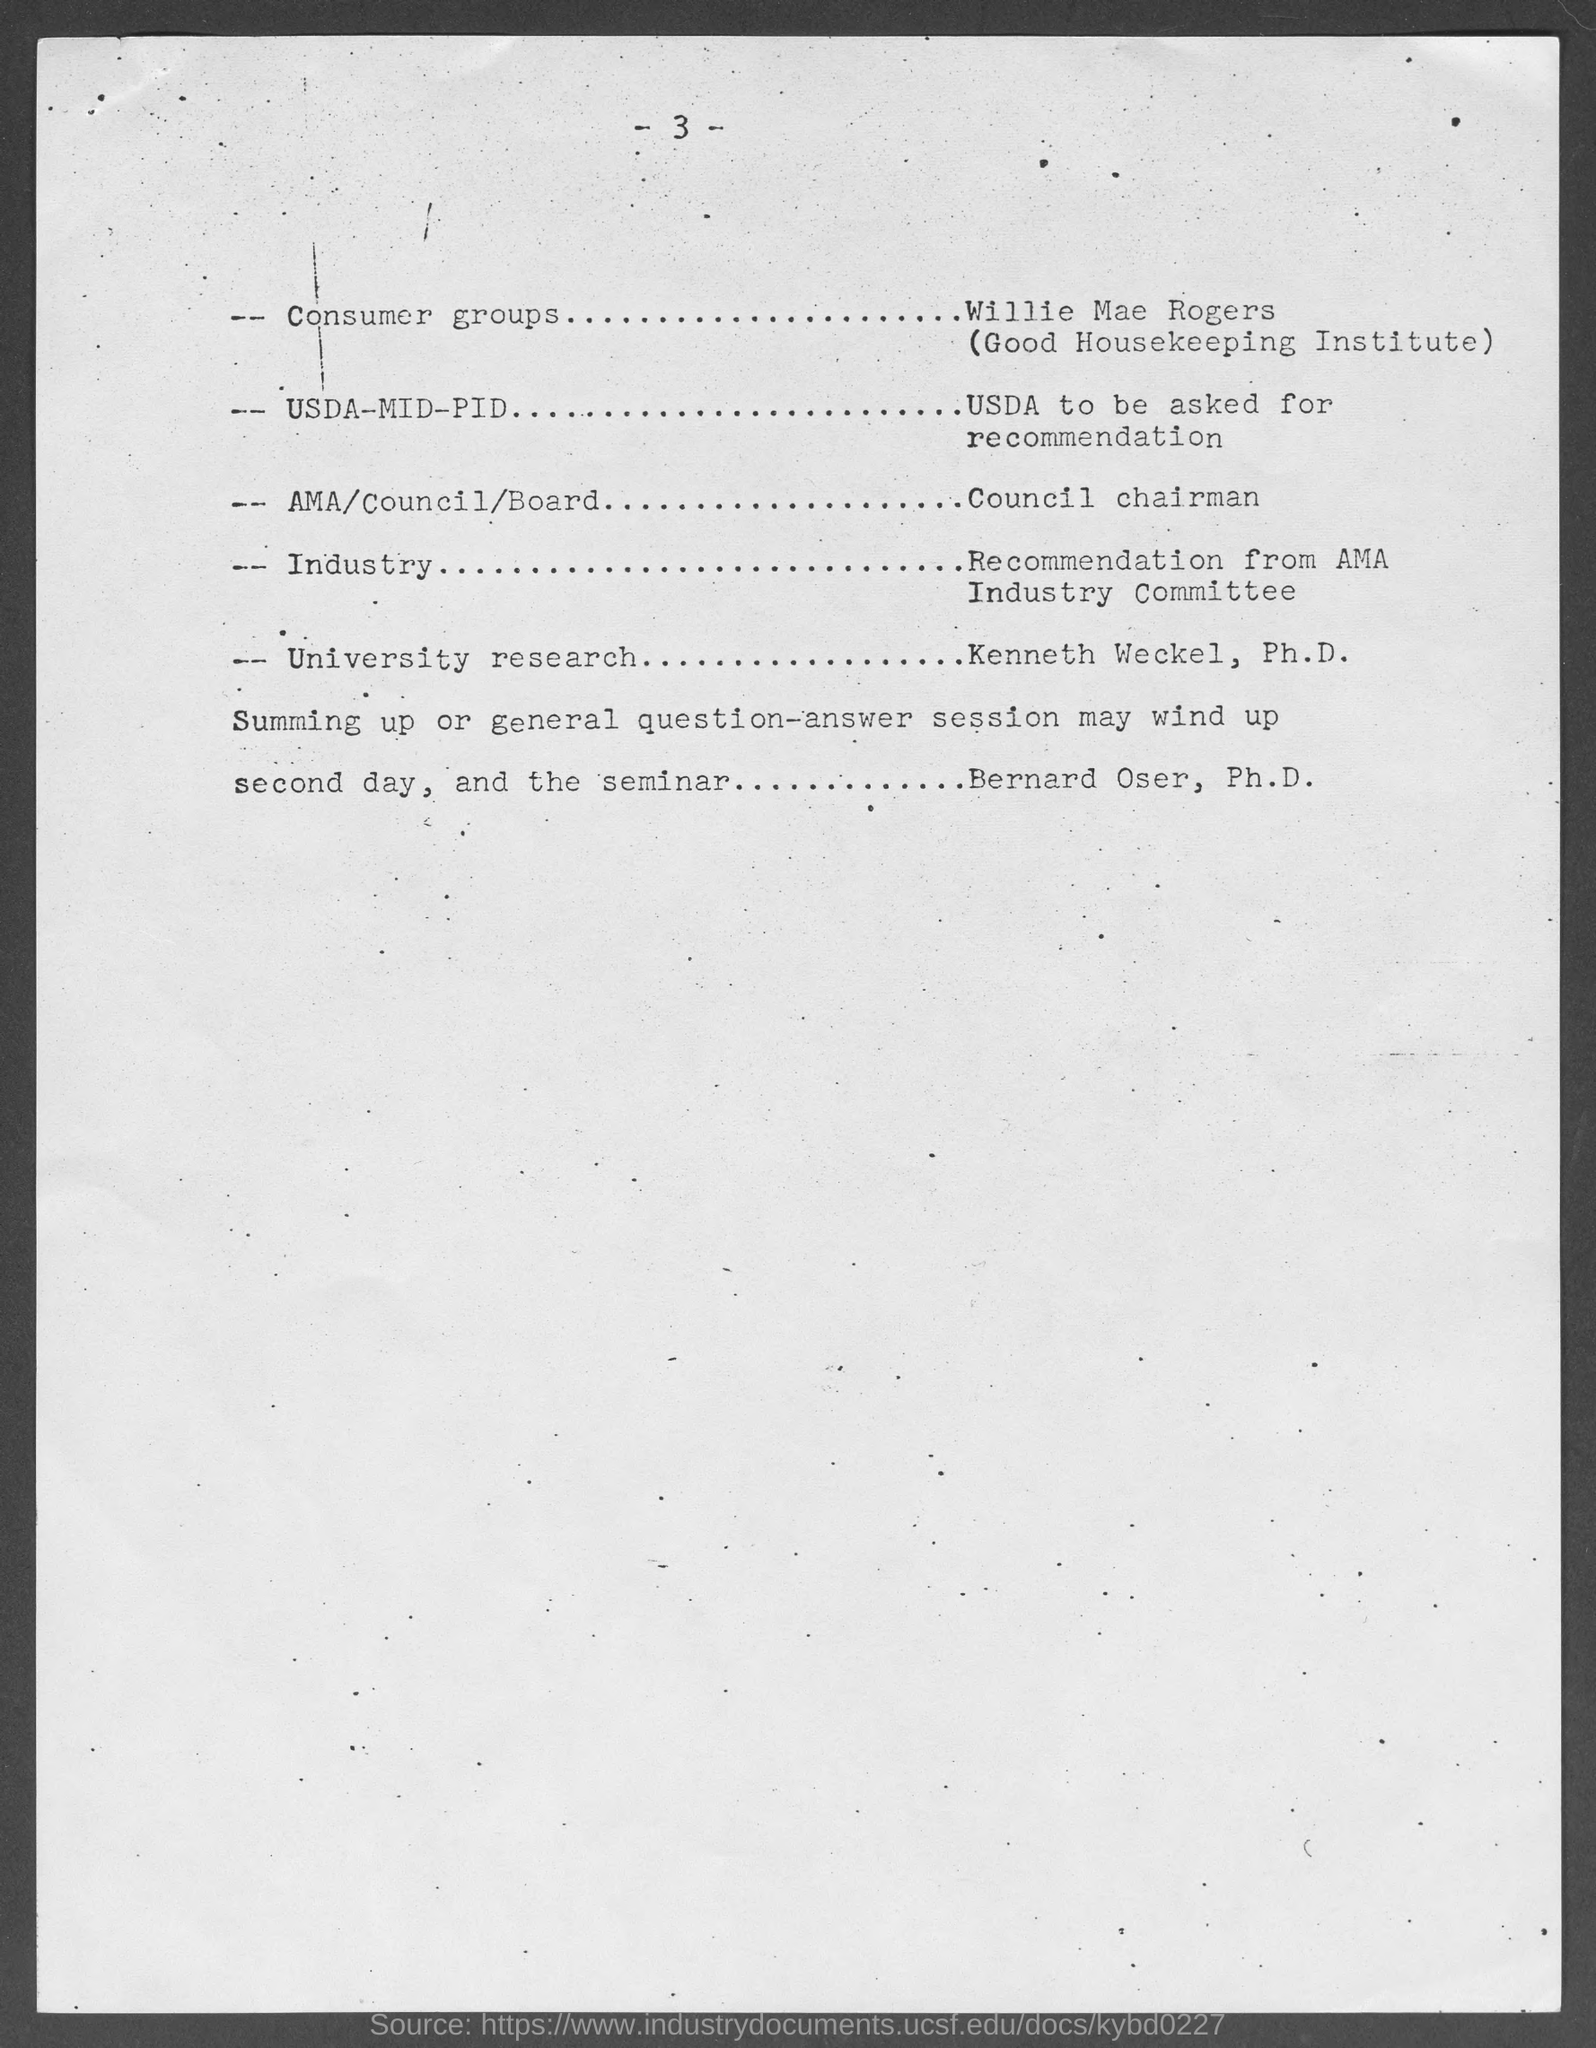Outline some significant characteristics in this image. The page number at the top of the page is 3. 